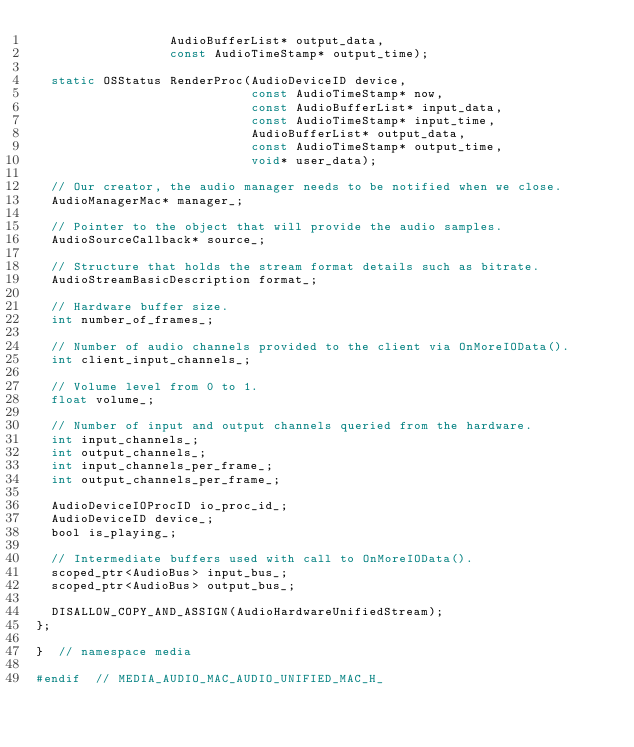Convert code to text. <code><loc_0><loc_0><loc_500><loc_500><_C_>                  AudioBufferList* output_data,
                  const AudioTimeStamp* output_time);

  static OSStatus RenderProc(AudioDeviceID device,
                             const AudioTimeStamp* now,
                             const AudioBufferList* input_data,
                             const AudioTimeStamp* input_time,
                             AudioBufferList* output_data,
                             const AudioTimeStamp* output_time,
                             void* user_data);

  // Our creator, the audio manager needs to be notified when we close.
  AudioManagerMac* manager_;

  // Pointer to the object that will provide the audio samples.
  AudioSourceCallback* source_;

  // Structure that holds the stream format details such as bitrate.
  AudioStreamBasicDescription format_;

  // Hardware buffer size.
  int number_of_frames_;

  // Number of audio channels provided to the client via OnMoreIOData().
  int client_input_channels_;

  // Volume level from 0 to 1.
  float volume_;

  // Number of input and output channels queried from the hardware.
  int input_channels_;
  int output_channels_;
  int input_channels_per_frame_;
  int output_channels_per_frame_;

  AudioDeviceIOProcID io_proc_id_;
  AudioDeviceID device_;
  bool is_playing_;

  // Intermediate buffers used with call to OnMoreIOData().
  scoped_ptr<AudioBus> input_bus_;
  scoped_ptr<AudioBus> output_bus_;

  DISALLOW_COPY_AND_ASSIGN(AudioHardwareUnifiedStream);
};

}  // namespace media

#endif  // MEDIA_AUDIO_MAC_AUDIO_UNIFIED_MAC_H_
</code> 